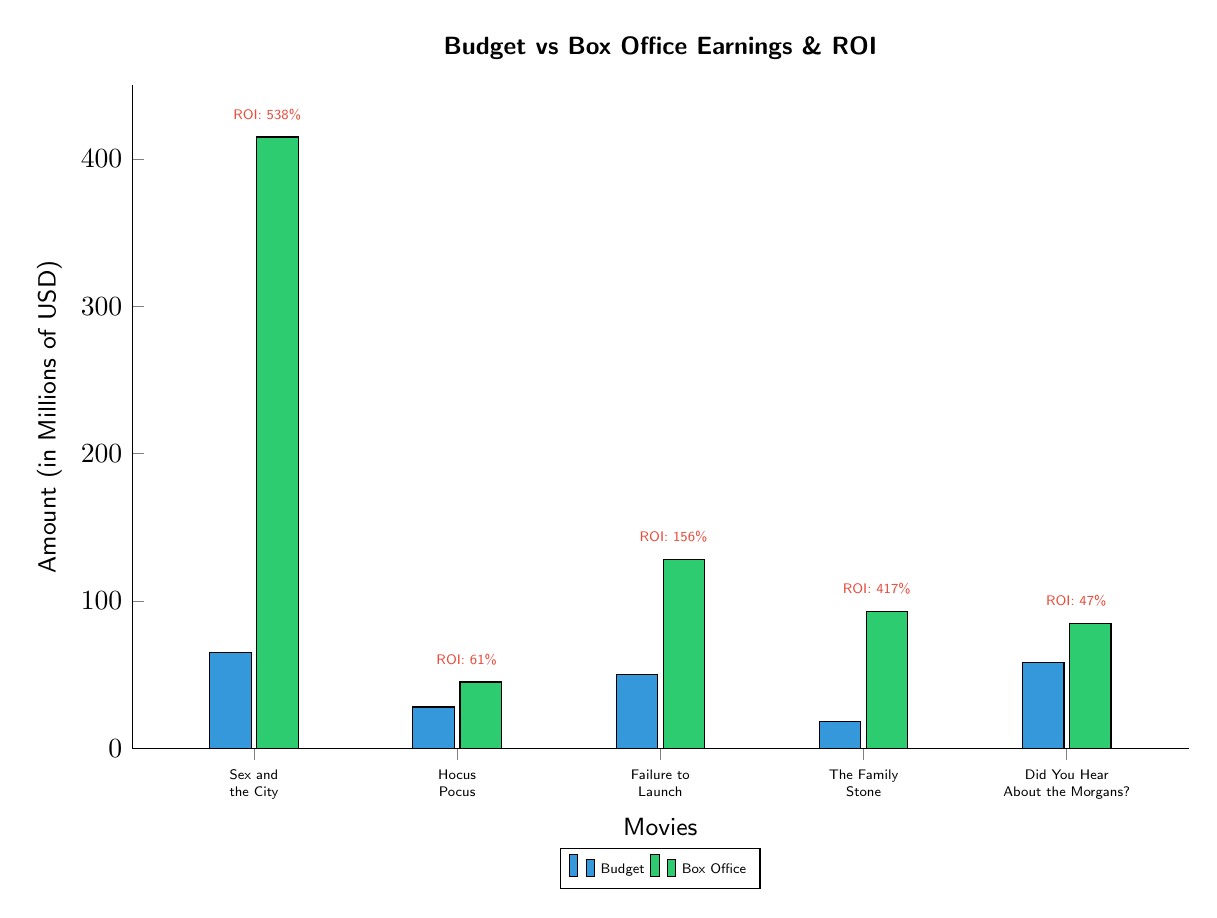What is the budget for "Sex and the City"? The diagram shows the budget for "Sex and the City," which is represented by the blue bar. The height of this bar reaches 65 million USD.
Answer: 65 million USD Which movie had the highest box office earnings? By observing the green bars representing box office earnings, "Sex and the City" has the tallest bar at 415 million USD.
Answer: "Sex and the City" What ROI percentage corresponds to "The Family Stone"? The ROI for "The Family Stone" is indicated next to its box office bar, which shows a value of 417%.
Answer: 417% How much was budgeted for "Hocus Pocus"? The budget for "Hocus Pocus" is represented by the blue bar, reaching 28 million USD as shown in the diagram.
Answer: 28 million USD Which movie has the lowest ROI? Comparing the ROI values placed near each bar, the lowest ROI is for "Did You Hear About the Morgans?" at 47%.
Answer: 47% What is the total budget for all the movies listed? The total budget can be found by adding each of the individual budgets: 65 + 28 + 50 + 18 + 58, which equals 219 million USD.
Answer: 219 million USD What is the box office earnings of "Failure to Launch"? The green bar for "Failure to Launch" reveals its box office earnings, which amounts to 128 million USD.
Answer: 128 million USD Which movie had a ROI higher than 100%? By reviewing the ROI values, "Sex and the City," "Failure to Launch," and "The Family Stone" all have ROIs above 100%, with values of 538%, 156%, and 417%, respectively.
Answer: "Sex and the City," "Failure to Launch," "The Family Stone" What is the combined box office of all movies? The total box office can be calculated by adding the individual box office earnings: 415 + 45 + 128 + 93 + 85, resulting in 766 million USD.
Answer: 766 million USD 